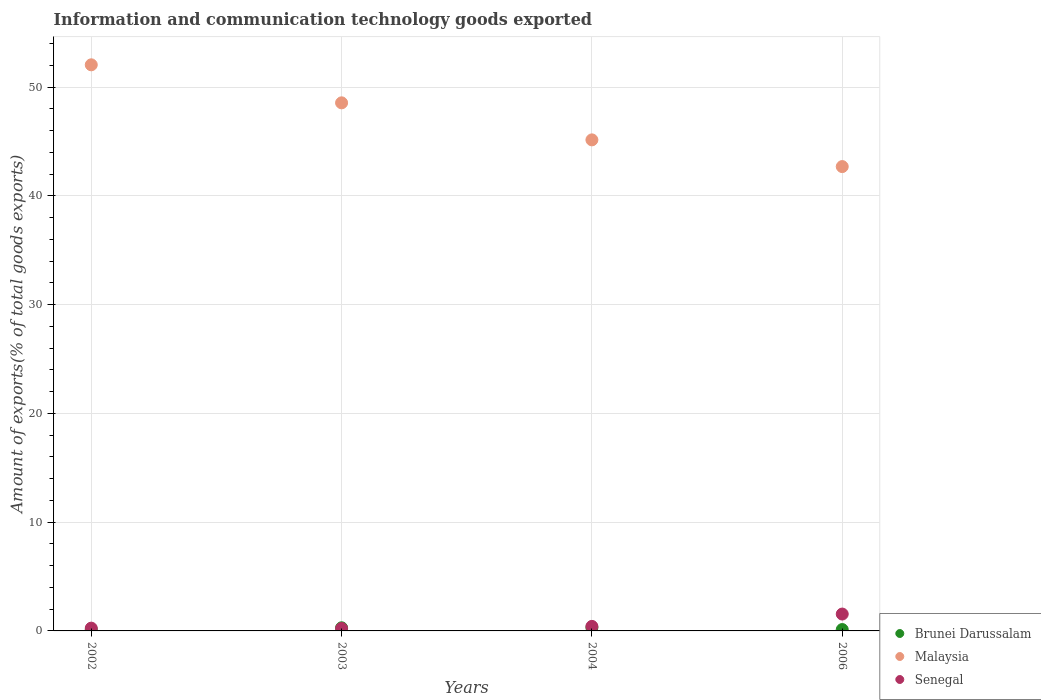How many different coloured dotlines are there?
Offer a very short reply. 3. What is the amount of goods exported in Senegal in 2003?
Offer a terse response. 0.23. Across all years, what is the maximum amount of goods exported in Senegal?
Your answer should be very brief. 1.55. Across all years, what is the minimum amount of goods exported in Senegal?
Your response must be concise. 0.23. In which year was the amount of goods exported in Senegal minimum?
Give a very brief answer. 2003. What is the total amount of goods exported in Senegal in the graph?
Your response must be concise. 2.45. What is the difference between the amount of goods exported in Malaysia in 2003 and that in 2004?
Your answer should be compact. 3.41. What is the difference between the amount of goods exported in Malaysia in 2006 and the amount of goods exported in Brunei Darussalam in 2004?
Ensure brevity in your answer.  42.4. What is the average amount of goods exported in Malaysia per year?
Provide a succinct answer. 47.12. In the year 2006, what is the difference between the amount of goods exported in Brunei Darussalam and amount of goods exported in Malaysia?
Provide a short and direct response. -42.58. What is the ratio of the amount of goods exported in Malaysia in 2002 to that in 2004?
Your answer should be compact. 1.15. Is the difference between the amount of goods exported in Brunei Darussalam in 2004 and 2006 greater than the difference between the amount of goods exported in Malaysia in 2004 and 2006?
Make the answer very short. No. What is the difference between the highest and the second highest amount of goods exported in Malaysia?
Offer a very short reply. 3.5. What is the difference between the highest and the lowest amount of goods exported in Brunei Darussalam?
Provide a succinct answer. 0.19. Is it the case that in every year, the sum of the amount of goods exported in Senegal and amount of goods exported in Malaysia  is greater than the amount of goods exported in Brunei Darussalam?
Your answer should be very brief. Yes. Does the amount of goods exported in Malaysia monotonically increase over the years?
Keep it short and to the point. No. What is the difference between two consecutive major ticks on the Y-axis?
Your answer should be compact. 10. Are the values on the major ticks of Y-axis written in scientific E-notation?
Make the answer very short. No. Does the graph contain any zero values?
Give a very brief answer. No. What is the title of the graph?
Your answer should be compact. Information and communication technology goods exported. Does "Montenegro" appear as one of the legend labels in the graph?
Provide a short and direct response. No. What is the label or title of the Y-axis?
Ensure brevity in your answer.  Amount of exports(% of total goods exports). What is the Amount of exports(% of total goods exports) in Brunei Darussalam in 2002?
Give a very brief answer. 0.11. What is the Amount of exports(% of total goods exports) in Malaysia in 2002?
Give a very brief answer. 52.06. What is the Amount of exports(% of total goods exports) in Senegal in 2002?
Provide a short and direct response. 0.25. What is the Amount of exports(% of total goods exports) in Brunei Darussalam in 2003?
Keep it short and to the point. 0.29. What is the Amount of exports(% of total goods exports) of Malaysia in 2003?
Keep it short and to the point. 48.57. What is the Amount of exports(% of total goods exports) of Senegal in 2003?
Your response must be concise. 0.23. What is the Amount of exports(% of total goods exports) of Brunei Darussalam in 2004?
Your response must be concise. 0.3. What is the Amount of exports(% of total goods exports) of Malaysia in 2004?
Give a very brief answer. 45.16. What is the Amount of exports(% of total goods exports) in Senegal in 2004?
Your answer should be compact. 0.42. What is the Amount of exports(% of total goods exports) of Brunei Darussalam in 2006?
Your answer should be compact. 0.13. What is the Amount of exports(% of total goods exports) in Malaysia in 2006?
Keep it short and to the point. 42.7. What is the Amount of exports(% of total goods exports) of Senegal in 2006?
Your answer should be very brief. 1.55. Across all years, what is the maximum Amount of exports(% of total goods exports) in Brunei Darussalam?
Your answer should be compact. 0.3. Across all years, what is the maximum Amount of exports(% of total goods exports) in Malaysia?
Make the answer very short. 52.06. Across all years, what is the maximum Amount of exports(% of total goods exports) of Senegal?
Provide a succinct answer. 1.55. Across all years, what is the minimum Amount of exports(% of total goods exports) in Brunei Darussalam?
Make the answer very short. 0.11. Across all years, what is the minimum Amount of exports(% of total goods exports) of Malaysia?
Keep it short and to the point. 42.7. Across all years, what is the minimum Amount of exports(% of total goods exports) of Senegal?
Provide a succinct answer. 0.23. What is the total Amount of exports(% of total goods exports) in Brunei Darussalam in the graph?
Provide a succinct answer. 0.83. What is the total Amount of exports(% of total goods exports) of Malaysia in the graph?
Keep it short and to the point. 188.49. What is the total Amount of exports(% of total goods exports) in Senegal in the graph?
Keep it short and to the point. 2.45. What is the difference between the Amount of exports(% of total goods exports) in Brunei Darussalam in 2002 and that in 2003?
Your answer should be compact. -0.17. What is the difference between the Amount of exports(% of total goods exports) in Malaysia in 2002 and that in 2003?
Ensure brevity in your answer.  3.5. What is the difference between the Amount of exports(% of total goods exports) of Senegal in 2002 and that in 2003?
Provide a succinct answer. 0.03. What is the difference between the Amount of exports(% of total goods exports) in Brunei Darussalam in 2002 and that in 2004?
Keep it short and to the point. -0.19. What is the difference between the Amount of exports(% of total goods exports) in Malaysia in 2002 and that in 2004?
Give a very brief answer. 6.9. What is the difference between the Amount of exports(% of total goods exports) in Senegal in 2002 and that in 2004?
Give a very brief answer. -0.16. What is the difference between the Amount of exports(% of total goods exports) in Brunei Darussalam in 2002 and that in 2006?
Offer a terse response. -0.01. What is the difference between the Amount of exports(% of total goods exports) in Malaysia in 2002 and that in 2006?
Make the answer very short. 9.36. What is the difference between the Amount of exports(% of total goods exports) of Senegal in 2002 and that in 2006?
Your answer should be compact. -1.3. What is the difference between the Amount of exports(% of total goods exports) of Brunei Darussalam in 2003 and that in 2004?
Keep it short and to the point. -0.02. What is the difference between the Amount of exports(% of total goods exports) of Malaysia in 2003 and that in 2004?
Keep it short and to the point. 3.41. What is the difference between the Amount of exports(% of total goods exports) in Senegal in 2003 and that in 2004?
Offer a terse response. -0.19. What is the difference between the Amount of exports(% of total goods exports) in Brunei Darussalam in 2003 and that in 2006?
Your answer should be very brief. 0.16. What is the difference between the Amount of exports(% of total goods exports) of Malaysia in 2003 and that in 2006?
Provide a succinct answer. 5.86. What is the difference between the Amount of exports(% of total goods exports) of Senegal in 2003 and that in 2006?
Give a very brief answer. -1.32. What is the difference between the Amount of exports(% of total goods exports) in Brunei Darussalam in 2004 and that in 2006?
Ensure brevity in your answer.  0.18. What is the difference between the Amount of exports(% of total goods exports) in Malaysia in 2004 and that in 2006?
Your answer should be very brief. 2.46. What is the difference between the Amount of exports(% of total goods exports) in Senegal in 2004 and that in 2006?
Your response must be concise. -1.14. What is the difference between the Amount of exports(% of total goods exports) of Brunei Darussalam in 2002 and the Amount of exports(% of total goods exports) of Malaysia in 2003?
Your response must be concise. -48.45. What is the difference between the Amount of exports(% of total goods exports) in Brunei Darussalam in 2002 and the Amount of exports(% of total goods exports) in Senegal in 2003?
Provide a succinct answer. -0.11. What is the difference between the Amount of exports(% of total goods exports) of Malaysia in 2002 and the Amount of exports(% of total goods exports) of Senegal in 2003?
Ensure brevity in your answer.  51.84. What is the difference between the Amount of exports(% of total goods exports) in Brunei Darussalam in 2002 and the Amount of exports(% of total goods exports) in Malaysia in 2004?
Offer a very short reply. -45.05. What is the difference between the Amount of exports(% of total goods exports) in Brunei Darussalam in 2002 and the Amount of exports(% of total goods exports) in Senegal in 2004?
Give a very brief answer. -0.3. What is the difference between the Amount of exports(% of total goods exports) in Malaysia in 2002 and the Amount of exports(% of total goods exports) in Senegal in 2004?
Keep it short and to the point. 51.65. What is the difference between the Amount of exports(% of total goods exports) of Brunei Darussalam in 2002 and the Amount of exports(% of total goods exports) of Malaysia in 2006?
Your answer should be compact. -42.59. What is the difference between the Amount of exports(% of total goods exports) in Brunei Darussalam in 2002 and the Amount of exports(% of total goods exports) in Senegal in 2006?
Offer a very short reply. -1.44. What is the difference between the Amount of exports(% of total goods exports) in Malaysia in 2002 and the Amount of exports(% of total goods exports) in Senegal in 2006?
Provide a short and direct response. 50.51. What is the difference between the Amount of exports(% of total goods exports) in Brunei Darussalam in 2003 and the Amount of exports(% of total goods exports) in Malaysia in 2004?
Your response must be concise. -44.87. What is the difference between the Amount of exports(% of total goods exports) of Brunei Darussalam in 2003 and the Amount of exports(% of total goods exports) of Senegal in 2004?
Give a very brief answer. -0.13. What is the difference between the Amount of exports(% of total goods exports) in Malaysia in 2003 and the Amount of exports(% of total goods exports) in Senegal in 2004?
Make the answer very short. 48.15. What is the difference between the Amount of exports(% of total goods exports) in Brunei Darussalam in 2003 and the Amount of exports(% of total goods exports) in Malaysia in 2006?
Your answer should be compact. -42.42. What is the difference between the Amount of exports(% of total goods exports) in Brunei Darussalam in 2003 and the Amount of exports(% of total goods exports) in Senegal in 2006?
Offer a terse response. -1.26. What is the difference between the Amount of exports(% of total goods exports) in Malaysia in 2003 and the Amount of exports(% of total goods exports) in Senegal in 2006?
Provide a short and direct response. 47.01. What is the difference between the Amount of exports(% of total goods exports) in Brunei Darussalam in 2004 and the Amount of exports(% of total goods exports) in Malaysia in 2006?
Your answer should be compact. -42.4. What is the difference between the Amount of exports(% of total goods exports) in Brunei Darussalam in 2004 and the Amount of exports(% of total goods exports) in Senegal in 2006?
Give a very brief answer. -1.25. What is the difference between the Amount of exports(% of total goods exports) in Malaysia in 2004 and the Amount of exports(% of total goods exports) in Senegal in 2006?
Provide a short and direct response. 43.61. What is the average Amount of exports(% of total goods exports) in Brunei Darussalam per year?
Your answer should be very brief. 0.21. What is the average Amount of exports(% of total goods exports) of Malaysia per year?
Offer a very short reply. 47.12. What is the average Amount of exports(% of total goods exports) of Senegal per year?
Offer a terse response. 0.61. In the year 2002, what is the difference between the Amount of exports(% of total goods exports) in Brunei Darussalam and Amount of exports(% of total goods exports) in Malaysia?
Ensure brevity in your answer.  -51.95. In the year 2002, what is the difference between the Amount of exports(% of total goods exports) in Brunei Darussalam and Amount of exports(% of total goods exports) in Senegal?
Ensure brevity in your answer.  -0.14. In the year 2002, what is the difference between the Amount of exports(% of total goods exports) in Malaysia and Amount of exports(% of total goods exports) in Senegal?
Keep it short and to the point. 51.81. In the year 2003, what is the difference between the Amount of exports(% of total goods exports) in Brunei Darussalam and Amount of exports(% of total goods exports) in Malaysia?
Offer a terse response. -48.28. In the year 2003, what is the difference between the Amount of exports(% of total goods exports) of Brunei Darussalam and Amount of exports(% of total goods exports) of Senegal?
Provide a short and direct response. 0.06. In the year 2003, what is the difference between the Amount of exports(% of total goods exports) of Malaysia and Amount of exports(% of total goods exports) of Senegal?
Provide a succinct answer. 48.34. In the year 2004, what is the difference between the Amount of exports(% of total goods exports) in Brunei Darussalam and Amount of exports(% of total goods exports) in Malaysia?
Offer a terse response. -44.86. In the year 2004, what is the difference between the Amount of exports(% of total goods exports) in Brunei Darussalam and Amount of exports(% of total goods exports) in Senegal?
Your response must be concise. -0.11. In the year 2004, what is the difference between the Amount of exports(% of total goods exports) of Malaysia and Amount of exports(% of total goods exports) of Senegal?
Give a very brief answer. 44.74. In the year 2006, what is the difference between the Amount of exports(% of total goods exports) of Brunei Darussalam and Amount of exports(% of total goods exports) of Malaysia?
Offer a very short reply. -42.58. In the year 2006, what is the difference between the Amount of exports(% of total goods exports) of Brunei Darussalam and Amount of exports(% of total goods exports) of Senegal?
Your response must be concise. -1.43. In the year 2006, what is the difference between the Amount of exports(% of total goods exports) of Malaysia and Amount of exports(% of total goods exports) of Senegal?
Offer a terse response. 41.15. What is the ratio of the Amount of exports(% of total goods exports) in Brunei Darussalam in 2002 to that in 2003?
Offer a very short reply. 0.39. What is the ratio of the Amount of exports(% of total goods exports) in Malaysia in 2002 to that in 2003?
Offer a very short reply. 1.07. What is the ratio of the Amount of exports(% of total goods exports) of Senegal in 2002 to that in 2003?
Ensure brevity in your answer.  1.12. What is the ratio of the Amount of exports(% of total goods exports) of Brunei Darussalam in 2002 to that in 2004?
Keep it short and to the point. 0.37. What is the ratio of the Amount of exports(% of total goods exports) of Malaysia in 2002 to that in 2004?
Offer a terse response. 1.15. What is the ratio of the Amount of exports(% of total goods exports) of Senegal in 2002 to that in 2004?
Your answer should be very brief. 0.61. What is the ratio of the Amount of exports(% of total goods exports) in Brunei Darussalam in 2002 to that in 2006?
Offer a terse response. 0.9. What is the ratio of the Amount of exports(% of total goods exports) of Malaysia in 2002 to that in 2006?
Provide a short and direct response. 1.22. What is the ratio of the Amount of exports(% of total goods exports) in Senegal in 2002 to that in 2006?
Provide a short and direct response. 0.16. What is the ratio of the Amount of exports(% of total goods exports) of Brunei Darussalam in 2003 to that in 2004?
Provide a short and direct response. 0.95. What is the ratio of the Amount of exports(% of total goods exports) in Malaysia in 2003 to that in 2004?
Offer a terse response. 1.08. What is the ratio of the Amount of exports(% of total goods exports) in Senegal in 2003 to that in 2004?
Ensure brevity in your answer.  0.54. What is the ratio of the Amount of exports(% of total goods exports) of Brunei Darussalam in 2003 to that in 2006?
Give a very brief answer. 2.28. What is the ratio of the Amount of exports(% of total goods exports) in Malaysia in 2003 to that in 2006?
Provide a succinct answer. 1.14. What is the ratio of the Amount of exports(% of total goods exports) in Senegal in 2003 to that in 2006?
Keep it short and to the point. 0.15. What is the ratio of the Amount of exports(% of total goods exports) of Brunei Darussalam in 2004 to that in 2006?
Offer a very short reply. 2.4. What is the ratio of the Amount of exports(% of total goods exports) of Malaysia in 2004 to that in 2006?
Offer a terse response. 1.06. What is the ratio of the Amount of exports(% of total goods exports) in Senegal in 2004 to that in 2006?
Ensure brevity in your answer.  0.27. What is the difference between the highest and the second highest Amount of exports(% of total goods exports) of Brunei Darussalam?
Ensure brevity in your answer.  0.02. What is the difference between the highest and the second highest Amount of exports(% of total goods exports) in Malaysia?
Make the answer very short. 3.5. What is the difference between the highest and the second highest Amount of exports(% of total goods exports) in Senegal?
Ensure brevity in your answer.  1.14. What is the difference between the highest and the lowest Amount of exports(% of total goods exports) of Brunei Darussalam?
Give a very brief answer. 0.19. What is the difference between the highest and the lowest Amount of exports(% of total goods exports) of Malaysia?
Your response must be concise. 9.36. What is the difference between the highest and the lowest Amount of exports(% of total goods exports) of Senegal?
Provide a short and direct response. 1.32. 